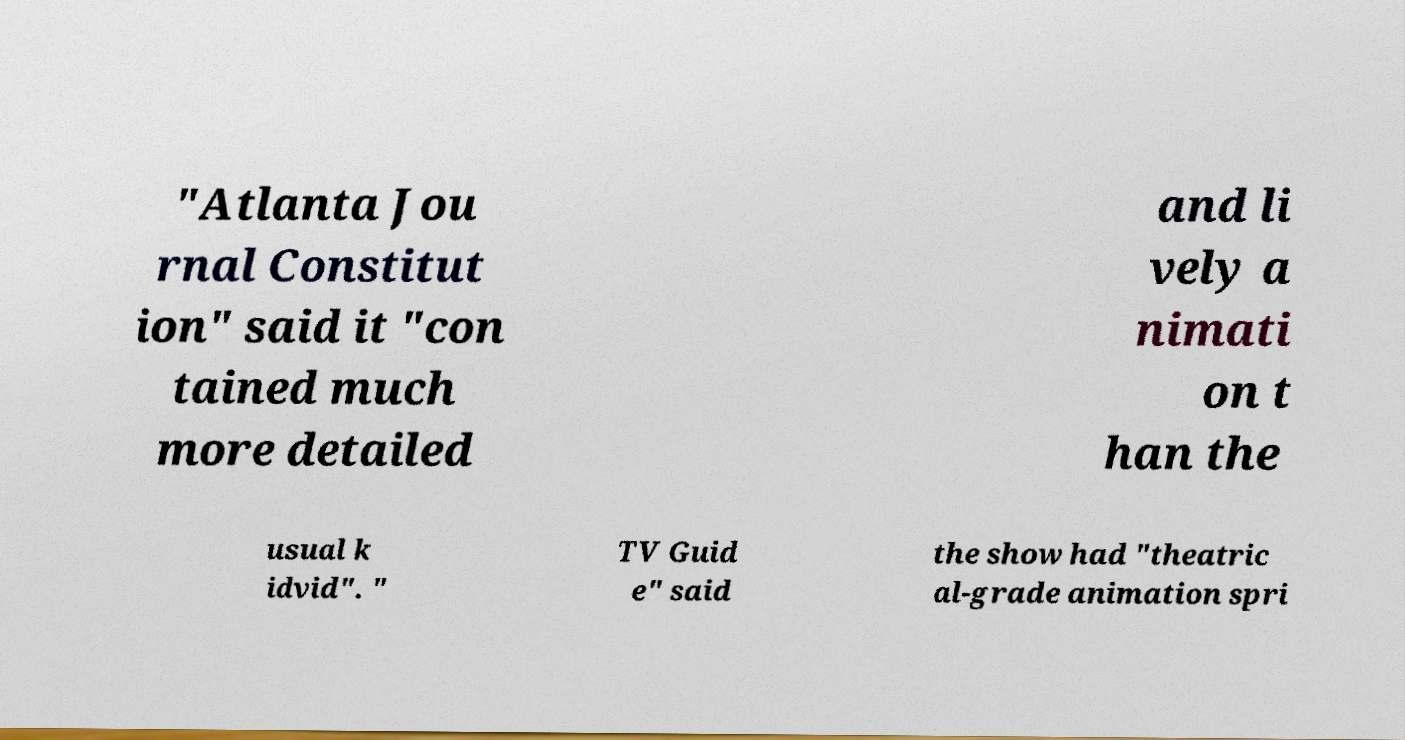There's text embedded in this image that I need extracted. Can you transcribe it verbatim? "Atlanta Jou rnal Constitut ion" said it "con tained much more detailed and li vely a nimati on t han the usual k idvid". " TV Guid e" said the show had "theatric al-grade animation spri 